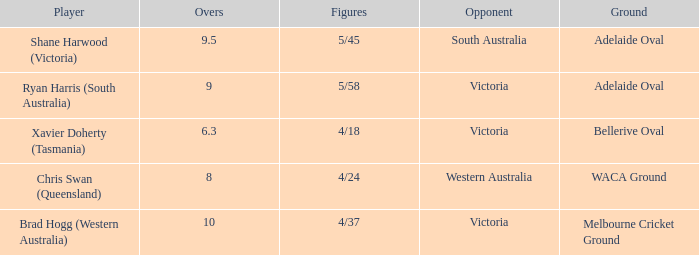What did Xavier Doherty (Tasmania) set as his highest Overs? 6.3. 